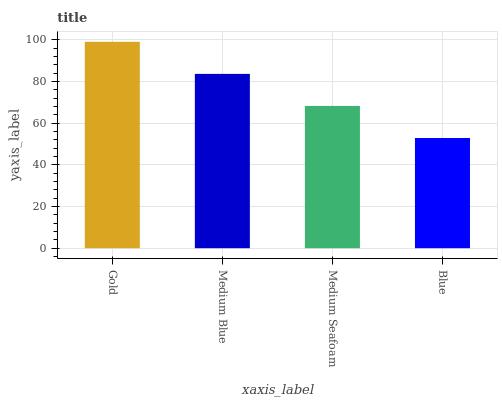Is Medium Blue the minimum?
Answer yes or no. No. Is Medium Blue the maximum?
Answer yes or no. No. Is Gold greater than Medium Blue?
Answer yes or no. Yes. Is Medium Blue less than Gold?
Answer yes or no. Yes. Is Medium Blue greater than Gold?
Answer yes or no. No. Is Gold less than Medium Blue?
Answer yes or no. No. Is Medium Blue the high median?
Answer yes or no. Yes. Is Medium Seafoam the low median?
Answer yes or no. Yes. Is Medium Seafoam the high median?
Answer yes or no. No. Is Gold the low median?
Answer yes or no. No. 